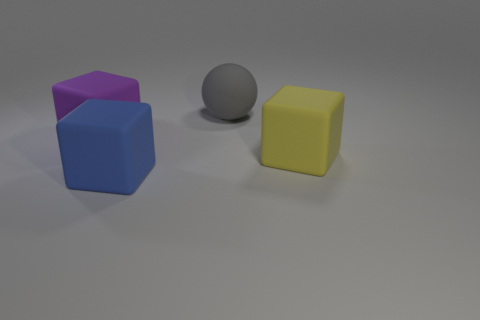What is the material of the gray ball that is the same size as the purple cube?
Provide a succinct answer. Rubber. The large thing that is both on the left side of the large gray sphere and right of the purple rubber cube has what shape?
Offer a very short reply. Cube. There is a matte ball that is the same size as the purple cube; what is its color?
Keep it short and to the point. Gray. There is a block to the right of the large matte sphere; is its size the same as the blue cube in front of the matte sphere?
Your answer should be very brief. Yes. There is a rubber object behind the matte block behind the large thing that is to the right of the gray thing; what is its size?
Your answer should be very brief. Large. What is the shape of the rubber object that is to the right of the rubber thing that is behind the purple rubber thing?
Offer a terse response. Cube. There is a big matte block on the right side of the large gray matte thing; is its color the same as the large sphere?
Provide a succinct answer. No. The large thing that is to the right of the blue object and behind the yellow object is what color?
Your answer should be compact. Gray. Are there any other large blue cubes made of the same material as the blue cube?
Your answer should be very brief. No. What size is the sphere?
Your answer should be compact. Large. 